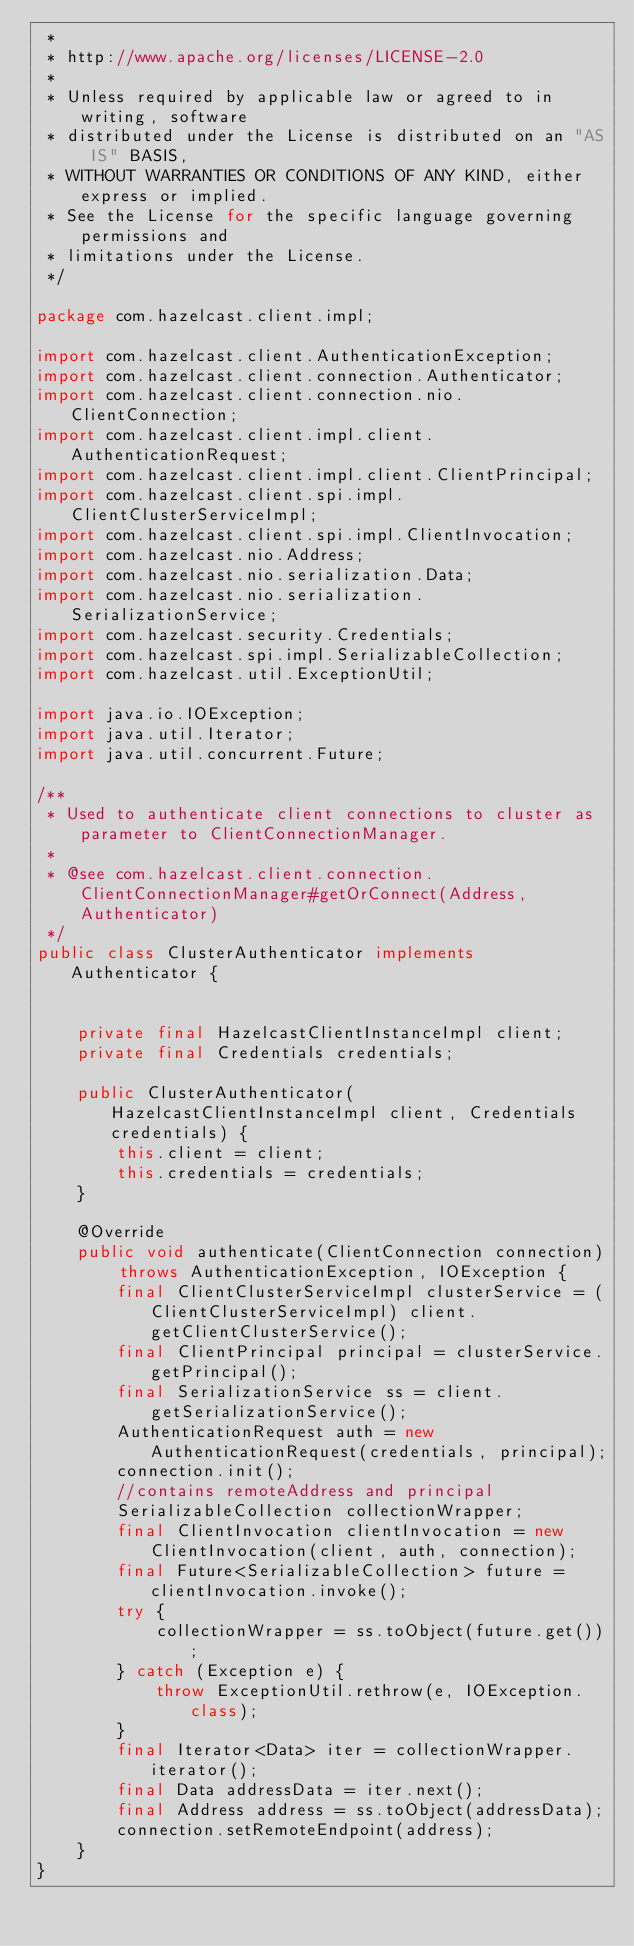Convert code to text. <code><loc_0><loc_0><loc_500><loc_500><_Java_> *
 * http://www.apache.org/licenses/LICENSE-2.0
 *
 * Unless required by applicable law or agreed to in writing, software
 * distributed under the License is distributed on an "AS IS" BASIS,
 * WITHOUT WARRANTIES OR CONDITIONS OF ANY KIND, either express or implied.
 * See the License for the specific language governing permissions and
 * limitations under the License.
 */

package com.hazelcast.client.impl;

import com.hazelcast.client.AuthenticationException;
import com.hazelcast.client.connection.Authenticator;
import com.hazelcast.client.connection.nio.ClientConnection;
import com.hazelcast.client.impl.client.AuthenticationRequest;
import com.hazelcast.client.impl.client.ClientPrincipal;
import com.hazelcast.client.spi.impl.ClientClusterServiceImpl;
import com.hazelcast.client.spi.impl.ClientInvocation;
import com.hazelcast.nio.Address;
import com.hazelcast.nio.serialization.Data;
import com.hazelcast.nio.serialization.SerializationService;
import com.hazelcast.security.Credentials;
import com.hazelcast.spi.impl.SerializableCollection;
import com.hazelcast.util.ExceptionUtil;

import java.io.IOException;
import java.util.Iterator;
import java.util.concurrent.Future;

/**
 * Used to authenticate client connections to cluster as parameter to ClientConnectionManager.
 *
 * @see com.hazelcast.client.connection.ClientConnectionManager#getOrConnect(Address, Authenticator)
 */
public class ClusterAuthenticator implements Authenticator {


    private final HazelcastClientInstanceImpl client;
    private final Credentials credentials;

    public ClusterAuthenticator(HazelcastClientInstanceImpl client, Credentials credentials) {
        this.client = client;
        this.credentials = credentials;
    }

    @Override
    public void authenticate(ClientConnection connection) throws AuthenticationException, IOException {
        final ClientClusterServiceImpl clusterService = (ClientClusterServiceImpl) client.getClientClusterService();
        final ClientPrincipal principal = clusterService.getPrincipal();
        final SerializationService ss = client.getSerializationService();
        AuthenticationRequest auth = new AuthenticationRequest(credentials, principal);
        connection.init();
        //contains remoteAddress and principal
        SerializableCollection collectionWrapper;
        final ClientInvocation clientInvocation = new ClientInvocation(client, auth, connection);
        final Future<SerializableCollection> future = clientInvocation.invoke();
        try {
            collectionWrapper = ss.toObject(future.get());
        } catch (Exception e) {
            throw ExceptionUtil.rethrow(e, IOException.class);
        }
        final Iterator<Data> iter = collectionWrapper.iterator();
        final Data addressData = iter.next();
        final Address address = ss.toObject(addressData);
        connection.setRemoteEndpoint(address);
    }
}
</code> 